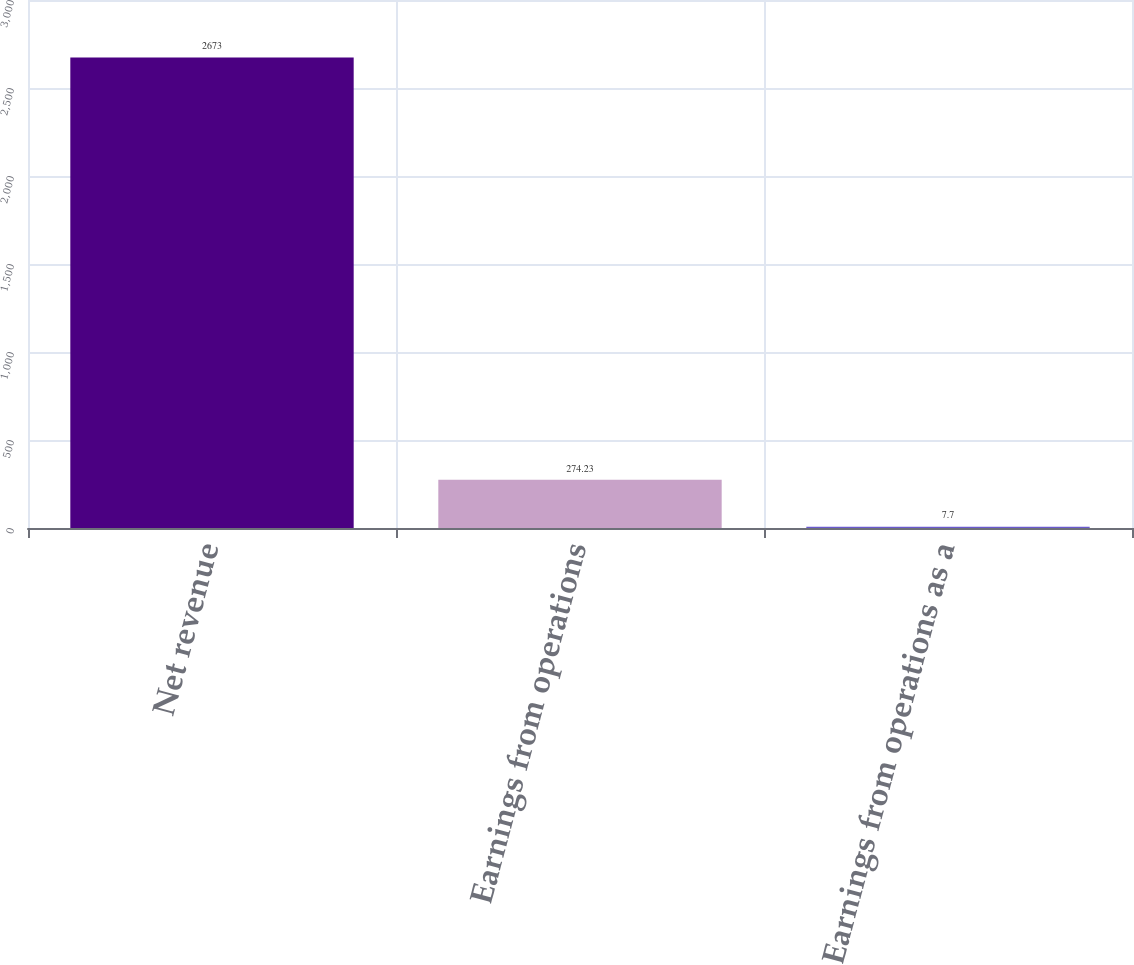<chart> <loc_0><loc_0><loc_500><loc_500><bar_chart><fcel>Net revenue<fcel>Earnings from operations<fcel>Earnings from operations as a<nl><fcel>2673<fcel>274.23<fcel>7.7<nl></chart> 